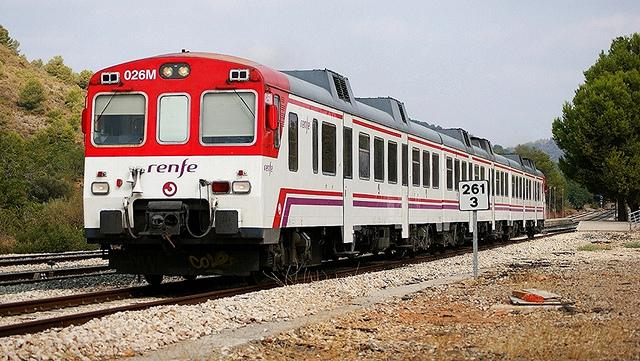Where does it say 026M?
Concise answer only. On train. What is this image of?
Quick response, please. Train. Where is the train heading to?
Keep it brief. Station. What numbers are on the sign?
Be succinct. 261 3. What color is the train?
Short answer required. White. 